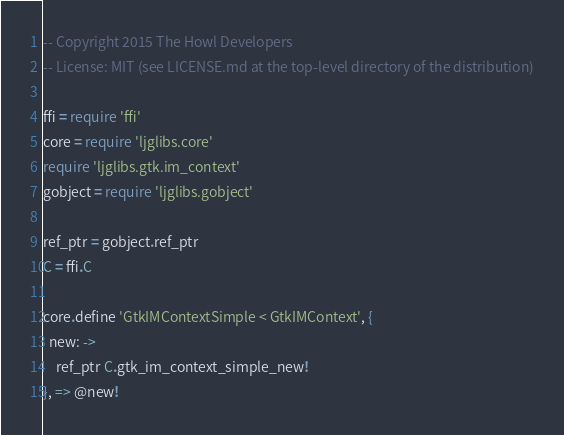<code> <loc_0><loc_0><loc_500><loc_500><_MoonScript_>-- Copyright 2015 The Howl Developers
-- License: MIT (see LICENSE.md at the top-level directory of the distribution)

ffi = require 'ffi'
core = require 'ljglibs.core'
require 'ljglibs.gtk.im_context'
gobject = require 'ljglibs.gobject'

ref_ptr = gobject.ref_ptr
C = ffi.C

core.define 'GtkIMContextSimple < GtkIMContext', {
  new: ->
    ref_ptr C.gtk_im_context_simple_new!
}, => @new!
</code> 